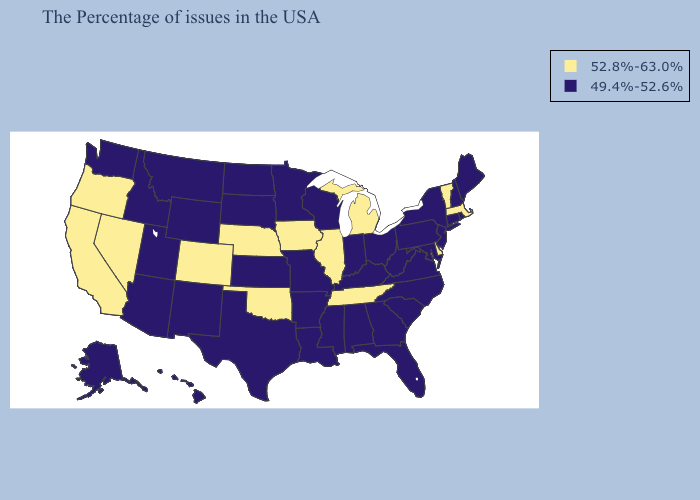Name the states that have a value in the range 49.4%-52.6%?
Quick response, please. Maine, Rhode Island, New Hampshire, Connecticut, New York, New Jersey, Maryland, Pennsylvania, Virginia, North Carolina, South Carolina, West Virginia, Ohio, Florida, Georgia, Kentucky, Indiana, Alabama, Wisconsin, Mississippi, Louisiana, Missouri, Arkansas, Minnesota, Kansas, Texas, South Dakota, North Dakota, Wyoming, New Mexico, Utah, Montana, Arizona, Idaho, Washington, Alaska, Hawaii. Among the states that border Missouri , does Kansas have the lowest value?
Answer briefly. Yes. Does Utah have the highest value in the West?
Answer briefly. No. What is the lowest value in states that border Utah?
Keep it brief. 49.4%-52.6%. Among the states that border Missouri , which have the lowest value?
Write a very short answer. Kentucky, Arkansas, Kansas. What is the highest value in states that border Michigan?
Write a very short answer. 49.4%-52.6%. Name the states that have a value in the range 49.4%-52.6%?
Quick response, please. Maine, Rhode Island, New Hampshire, Connecticut, New York, New Jersey, Maryland, Pennsylvania, Virginia, North Carolina, South Carolina, West Virginia, Ohio, Florida, Georgia, Kentucky, Indiana, Alabama, Wisconsin, Mississippi, Louisiana, Missouri, Arkansas, Minnesota, Kansas, Texas, South Dakota, North Dakota, Wyoming, New Mexico, Utah, Montana, Arizona, Idaho, Washington, Alaska, Hawaii. Name the states that have a value in the range 49.4%-52.6%?
Concise answer only. Maine, Rhode Island, New Hampshire, Connecticut, New York, New Jersey, Maryland, Pennsylvania, Virginia, North Carolina, South Carolina, West Virginia, Ohio, Florida, Georgia, Kentucky, Indiana, Alabama, Wisconsin, Mississippi, Louisiana, Missouri, Arkansas, Minnesota, Kansas, Texas, South Dakota, North Dakota, Wyoming, New Mexico, Utah, Montana, Arizona, Idaho, Washington, Alaska, Hawaii. Is the legend a continuous bar?
Quick response, please. No. Name the states that have a value in the range 49.4%-52.6%?
Quick response, please. Maine, Rhode Island, New Hampshire, Connecticut, New York, New Jersey, Maryland, Pennsylvania, Virginia, North Carolina, South Carolina, West Virginia, Ohio, Florida, Georgia, Kentucky, Indiana, Alabama, Wisconsin, Mississippi, Louisiana, Missouri, Arkansas, Minnesota, Kansas, Texas, South Dakota, North Dakota, Wyoming, New Mexico, Utah, Montana, Arizona, Idaho, Washington, Alaska, Hawaii. What is the value of Montana?
Short answer required. 49.4%-52.6%. Which states have the lowest value in the Northeast?
Write a very short answer. Maine, Rhode Island, New Hampshire, Connecticut, New York, New Jersey, Pennsylvania. Which states have the lowest value in the West?
Keep it brief. Wyoming, New Mexico, Utah, Montana, Arizona, Idaho, Washington, Alaska, Hawaii. Does South Dakota have a higher value than Alaska?
Quick response, please. No. Among the states that border New Hampshire , which have the highest value?
Quick response, please. Massachusetts, Vermont. 